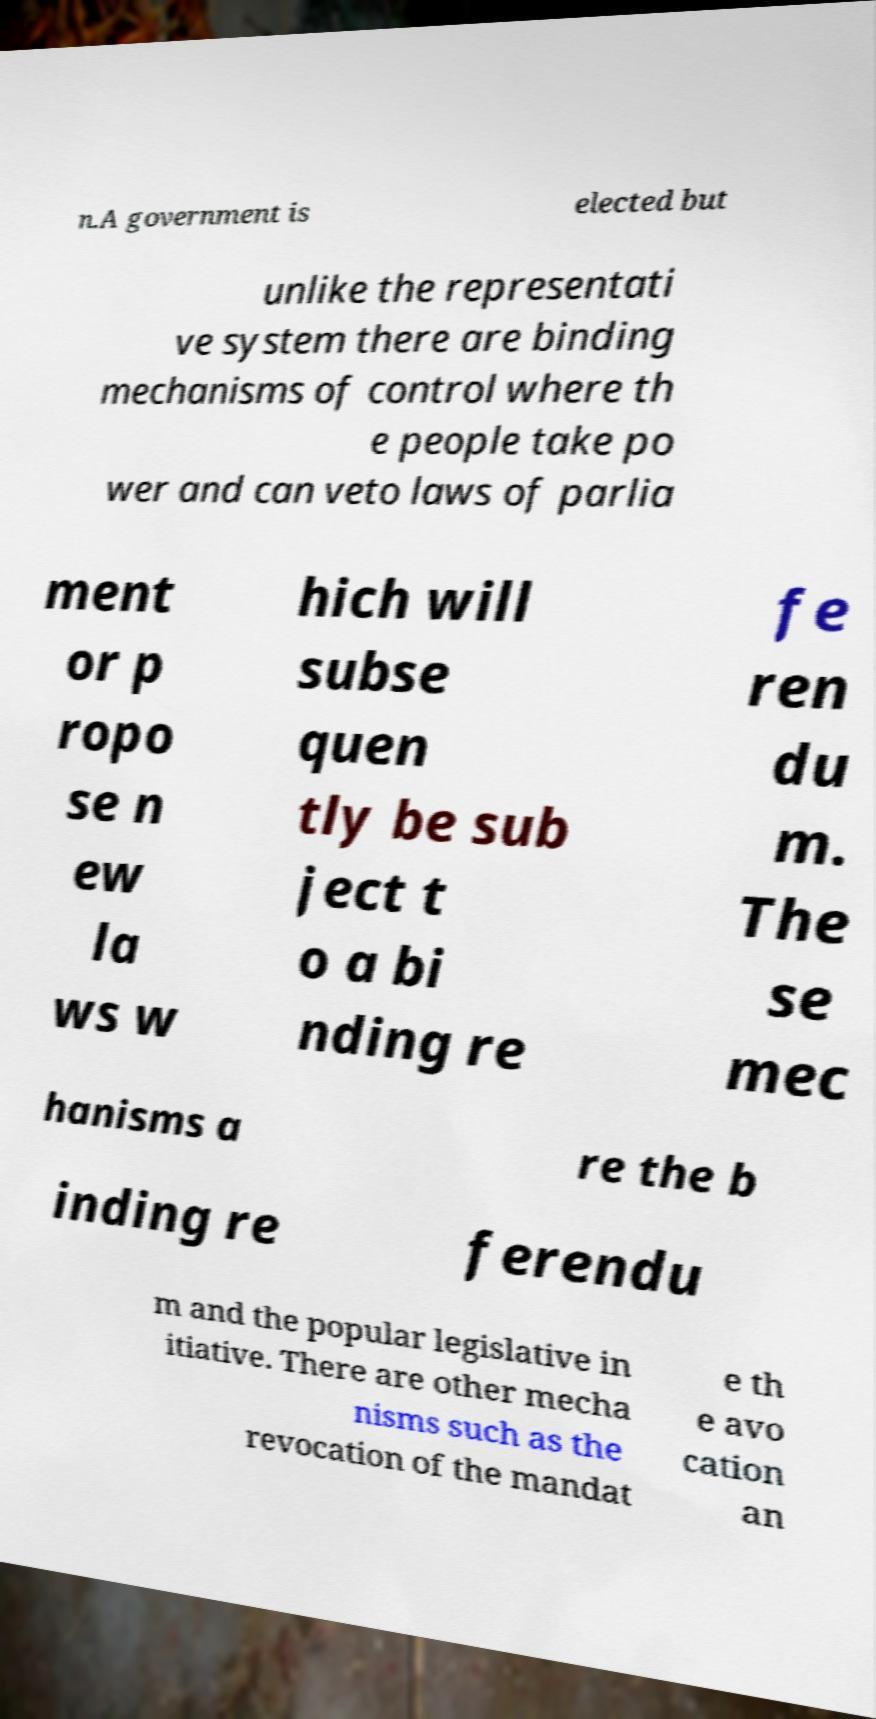Please identify and transcribe the text found in this image. n.A government is elected but unlike the representati ve system there are binding mechanisms of control where th e people take po wer and can veto laws of parlia ment or p ropo se n ew la ws w hich will subse quen tly be sub ject t o a bi nding re fe ren du m. The se mec hanisms a re the b inding re ferendu m and the popular legislative in itiative. There are other mecha nisms such as the revocation of the mandat e th e avo cation an 